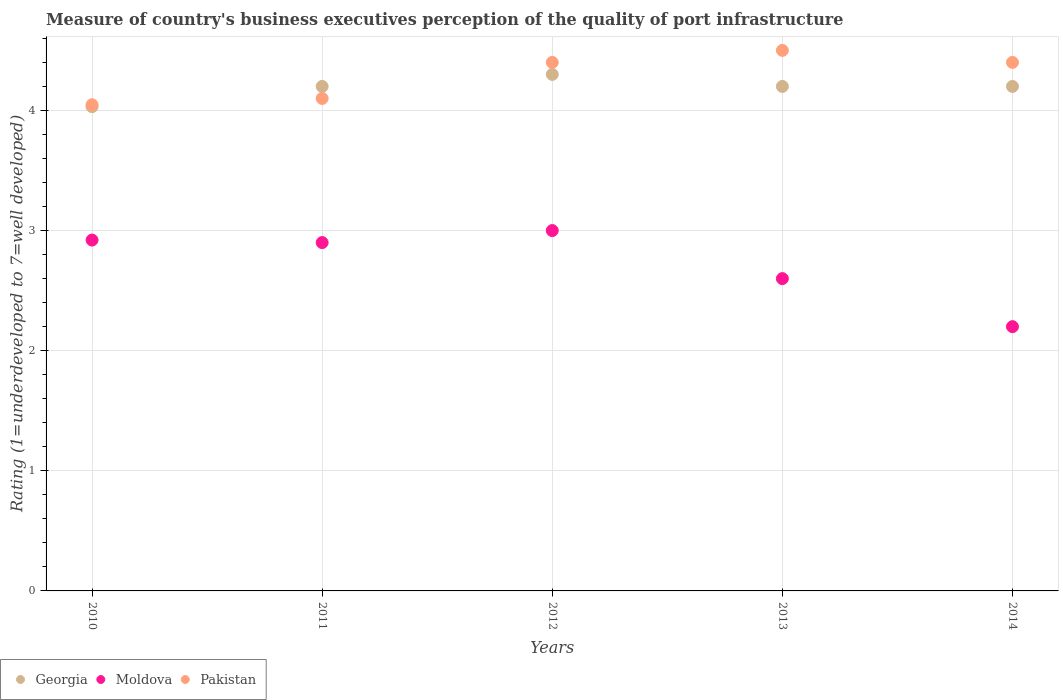How many different coloured dotlines are there?
Ensure brevity in your answer.  3. Across all years, what is the maximum ratings of the quality of port infrastructure in Georgia?
Provide a short and direct response. 4.3. Across all years, what is the minimum ratings of the quality of port infrastructure in Pakistan?
Your response must be concise. 4.05. What is the total ratings of the quality of port infrastructure in Pakistan in the graph?
Offer a terse response. 21.45. What is the difference between the ratings of the quality of port infrastructure in Pakistan in 2011 and that in 2013?
Offer a very short reply. -0.4. What is the difference between the ratings of the quality of port infrastructure in Moldova in 2013 and the ratings of the quality of port infrastructure in Pakistan in 2014?
Ensure brevity in your answer.  -1.8. What is the average ratings of the quality of port infrastructure in Moldova per year?
Your response must be concise. 2.72. In the year 2011, what is the difference between the ratings of the quality of port infrastructure in Georgia and ratings of the quality of port infrastructure in Moldova?
Make the answer very short. 1.3. What is the ratio of the ratings of the quality of port infrastructure in Pakistan in 2011 to that in 2013?
Offer a terse response. 0.91. Is the ratings of the quality of port infrastructure in Georgia in 2013 less than that in 2014?
Offer a terse response. No. What is the difference between the highest and the second highest ratings of the quality of port infrastructure in Moldova?
Your response must be concise. 0.08. What is the difference between the highest and the lowest ratings of the quality of port infrastructure in Pakistan?
Make the answer very short. 0.45. Is the sum of the ratings of the quality of port infrastructure in Pakistan in 2010 and 2013 greater than the maximum ratings of the quality of port infrastructure in Moldova across all years?
Offer a very short reply. Yes. Is it the case that in every year, the sum of the ratings of the quality of port infrastructure in Georgia and ratings of the quality of port infrastructure in Moldova  is greater than the ratings of the quality of port infrastructure in Pakistan?
Give a very brief answer. Yes. How many dotlines are there?
Ensure brevity in your answer.  3. Where does the legend appear in the graph?
Make the answer very short. Bottom left. What is the title of the graph?
Keep it short and to the point. Measure of country's business executives perception of the quality of port infrastructure. Does "Vanuatu" appear as one of the legend labels in the graph?
Make the answer very short. No. What is the label or title of the X-axis?
Provide a succinct answer. Years. What is the label or title of the Y-axis?
Your answer should be compact. Rating (1=underdeveloped to 7=well developed). What is the Rating (1=underdeveloped to 7=well developed) in Georgia in 2010?
Ensure brevity in your answer.  4.03. What is the Rating (1=underdeveloped to 7=well developed) of Moldova in 2010?
Offer a very short reply. 2.92. What is the Rating (1=underdeveloped to 7=well developed) in Pakistan in 2010?
Give a very brief answer. 4.05. What is the Rating (1=underdeveloped to 7=well developed) of Georgia in 2011?
Provide a short and direct response. 4.2. What is the Rating (1=underdeveloped to 7=well developed) in Moldova in 2011?
Give a very brief answer. 2.9. What is the Rating (1=underdeveloped to 7=well developed) in Pakistan in 2011?
Offer a terse response. 4.1. What is the Rating (1=underdeveloped to 7=well developed) of Georgia in 2012?
Your response must be concise. 4.3. What is the Rating (1=underdeveloped to 7=well developed) of Pakistan in 2012?
Provide a succinct answer. 4.4. What is the Rating (1=underdeveloped to 7=well developed) of Georgia in 2013?
Provide a succinct answer. 4.2. What is the Rating (1=underdeveloped to 7=well developed) in Pakistan in 2013?
Provide a short and direct response. 4.5. What is the Rating (1=underdeveloped to 7=well developed) in Georgia in 2014?
Provide a succinct answer. 4.2. What is the Rating (1=underdeveloped to 7=well developed) in Pakistan in 2014?
Keep it short and to the point. 4.4. Across all years, what is the maximum Rating (1=underdeveloped to 7=well developed) of Moldova?
Your answer should be compact. 3. Across all years, what is the minimum Rating (1=underdeveloped to 7=well developed) in Georgia?
Keep it short and to the point. 4.03. Across all years, what is the minimum Rating (1=underdeveloped to 7=well developed) in Pakistan?
Make the answer very short. 4.05. What is the total Rating (1=underdeveloped to 7=well developed) in Georgia in the graph?
Your response must be concise. 20.93. What is the total Rating (1=underdeveloped to 7=well developed) of Moldova in the graph?
Make the answer very short. 13.62. What is the total Rating (1=underdeveloped to 7=well developed) of Pakistan in the graph?
Your response must be concise. 21.45. What is the difference between the Rating (1=underdeveloped to 7=well developed) of Georgia in 2010 and that in 2011?
Offer a terse response. -0.17. What is the difference between the Rating (1=underdeveloped to 7=well developed) in Moldova in 2010 and that in 2011?
Provide a short and direct response. 0.02. What is the difference between the Rating (1=underdeveloped to 7=well developed) in Pakistan in 2010 and that in 2011?
Your answer should be compact. -0.05. What is the difference between the Rating (1=underdeveloped to 7=well developed) of Georgia in 2010 and that in 2012?
Make the answer very short. -0.27. What is the difference between the Rating (1=underdeveloped to 7=well developed) in Moldova in 2010 and that in 2012?
Your answer should be compact. -0.08. What is the difference between the Rating (1=underdeveloped to 7=well developed) of Pakistan in 2010 and that in 2012?
Offer a very short reply. -0.35. What is the difference between the Rating (1=underdeveloped to 7=well developed) of Georgia in 2010 and that in 2013?
Offer a very short reply. -0.17. What is the difference between the Rating (1=underdeveloped to 7=well developed) in Moldova in 2010 and that in 2013?
Provide a short and direct response. 0.32. What is the difference between the Rating (1=underdeveloped to 7=well developed) in Pakistan in 2010 and that in 2013?
Your answer should be very brief. -0.45. What is the difference between the Rating (1=underdeveloped to 7=well developed) in Georgia in 2010 and that in 2014?
Make the answer very short. -0.17. What is the difference between the Rating (1=underdeveloped to 7=well developed) in Moldova in 2010 and that in 2014?
Your response must be concise. 0.72. What is the difference between the Rating (1=underdeveloped to 7=well developed) in Pakistan in 2010 and that in 2014?
Your answer should be compact. -0.35. What is the difference between the Rating (1=underdeveloped to 7=well developed) of Georgia in 2011 and that in 2013?
Your answer should be very brief. 0. What is the difference between the Rating (1=underdeveloped to 7=well developed) in Pakistan in 2011 and that in 2013?
Make the answer very short. -0.4. What is the difference between the Rating (1=underdeveloped to 7=well developed) of Pakistan in 2011 and that in 2014?
Provide a succinct answer. -0.3. What is the difference between the Rating (1=underdeveloped to 7=well developed) of Moldova in 2012 and that in 2013?
Keep it short and to the point. 0.4. What is the difference between the Rating (1=underdeveloped to 7=well developed) of Pakistan in 2012 and that in 2013?
Ensure brevity in your answer.  -0.1. What is the difference between the Rating (1=underdeveloped to 7=well developed) in Moldova in 2012 and that in 2014?
Give a very brief answer. 0.8. What is the difference between the Rating (1=underdeveloped to 7=well developed) in Georgia in 2013 and that in 2014?
Your answer should be very brief. 0. What is the difference between the Rating (1=underdeveloped to 7=well developed) in Georgia in 2010 and the Rating (1=underdeveloped to 7=well developed) in Moldova in 2011?
Give a very brief answer. 1.13. What is the difference between the Rating (1=underdeveloped to 7=well developed) of Georgia in 2010 and the Rating (1=underdeveloped to 7=well developed) of Pakistan in 2011?
Offer a terse response. -0.07. What is the difference between the Rating (1=underdeveloped to 7=well developed) in Moldova in 2010 and the Rating (1=underdeveloped to 7=well developed) in Pakistan in 2011?
Give a very brief answer. -1.18. What is the difference between the Rating (1=underdeveloped to 7=well developed) in Georgia in 2010 and the Rating (1=underdeveloped to 7=well developed) in Moldova in 2012?
Offer a terse response. 1.03. What is the difference between the Rating (1=underdeveloped to 7=well developed) of Georgia in 2010 and the Rating (1=underdeveloped to 7=well developed) of Pakistan in 2012?
Your response must be concise. -0.37. What is the difference between the Rating (1=underdeveloped to 7=well developed) in Moldova in 2010 and the Rating (1=underdeveloped to 7=well developed) in Pakistan in 2012?
Your answer should be very brief. -1.48. What is the difference between the Rating (1=underdeveloped to 7=well developed) of Georgia in 2010 and the Rating (1=underdeveloped to 7=well developed) of Moldova in 2013?
Ensure brevity in your answer.  1.43. What is the difference between the Rating (1=underdeveloped to 7=well developed) in Georgia in 2010 and the Rating (1=underdeveloped to 7=well developed) in Pakistan in 2013?
Make the answer very short. -0.47. What is the difference between the Rating (1=underdeveloped to 7=well developed) of Moldova in 2010 and the Rating (1=underdeveloped to 7=well developed) of Pakistan in 2013?
Keep it short and to the point. -1.58. What is the difference between the Rating (1=underdeveloped to 7=well developed) in Georgia in 2010 and the Rating (1=underdeveloped to 7=well developed) in Moldova in 2014?
Make the answer very short. 1.83. What is the difference between the Rating (1=underdeveloped to 7=well developed) in Georgia in 2010 and the Rating (1=underdeveloped to 7=well developed) in Pakistan in 2014?
Offer a very short reply. -0.37. What is the difference between the Rating (1=underdeveloped to 7=well developed) of Moldova in 2010 and the Rating (1=underdeveloped to 7=well developed) of Pakistan in 2014?
Provide a succinct answer. -1.48. What is the difference between the Rating (1=underdeveloped to 7=well developed) in Georgia in 2011 and the Rating (1=underdeveloped to 7=well developed) in Moldova in 2012?
Your answer should be compact. 1.2. What is the difference between the Rating (1=underdeveloped to 7=well developed) in Georgia in 2011 and the Rating (1=underdeveloped to 7=well developed) in Pakistan in 2012?
Ensure brevity in your answer.  -0.2. What is the difference between the Rating (1=underdeveloped to 7=well developed) of Georgia in 2011 and the Rating (1=underdeveloped to 7=well developed) of Pakistan in 2014?
Keep it short and to the point. -0.2. What is the difference between the Rating (1=underdeveloped to 7=well developed) of Georgia in 2012 and the Rating (1=underdeveloped to 7=well developed) of Pakistan in 2013?
Your response must be concise. -0.2. What is the difference between the Rating (1=underdeveloped to 7=well developed) of Moldova in 2012 and the Rating (1=underdeveloped to 7=well developed) of Pakistan in 2013?
Give a very brief answer. -1.5. What is the difference between the Rating (1=underdeveloped to 7=well developed) of Georgia in 2012 and the Rating (1=underdeveloped to 7=well developed) of Pakistan in 2014?
Ensure brevity in your answer.  -0.1. What is the difference between the Rating (1=underdeveloped to 7=well developed) in Georgia in 2013 and the Rating (1=underdeveloped to 7=well developed) in Moldova in 2014?
Offer a terse response. 2. What is the difference between the Rating (1=underdeveloped to 7=well developed) in Moldova in 2013 and the Rating (1=underdeveloped to 7=well developed) in Pakistan in 2014?
Your answer should be very brief. -1.8. What is the average Rating (1=underdeveloped to 7=well developed) in Georgia per year?
Your answer should be very brief. 4.19. What is the average Rating (1=underdeveloped to 7=well developed) of Moldova per year?
Ensure brevity in your answer.  2.72. What is the average Rating (1=underdeveloped to 7=well developed) in Pakistan per year?
Provide a short and direct response. 4.29. In the year 2010, what is the difference between the Rating (1=underdeveloped to 7=well developed) in Georgia and Rating (1=underdeveloped to 7=well developed) in Moldova?
Your answer should be compact. 1.11. In the year 2010, what is the difference between the Rating (1=underdeveloped to 7=well developed) of Georgia and Rating (1=underdeveloped to 7=well developed) of Pakistan?
Keep it short and to the point. -0.02. In the year 2010, what is the difference between the Rating (1=underdeveloped to 7=well developed) of Moldova and Rating (1=underdeveloped to 7=well developed) of Pakistan?
Provide a short and direct response. -1.13. In the year 2011, what is the difference between the Rating (1=underdeveloped to 7=well developed) of Georgia and Rating (1=underdeveloped to 7=well developed) of Moldova?
Your answer should be compact. 1.3. In the year 2011, what is the difference between the Rating (1=underdeveloped to 7=well developed) of Georgia and Rating (1=underdeveloped to 7=well developed) of Pakistan?
Provide a short and direct response. 0.1. In the year 2012, what is the difference between the Rating (1=underdeveloped to 7=well developed) of Georgia and Rating (1=underdeveloped to 7=well developed) of Moldova?
Offer a terse response. 1.3. In the year 2012, what is the difference between the Rating (1=underdeveloped to 7=well developed) in Georgia and Rating (1=underdeveloped to 7=well developed) in Pakistan?
Provide a short and direct response. -0.1. In the year 2013, what is the difference between the Rating (1=underdeveloped to 7=well developed) of Georgia and Rating (1=underdeveloped to 7=well developed) of Pakistan?
Your answer should be compact. -0.3. In the year 2014, what is the difference between the Rating (1=underdeveloped to 7=well developed) of Georgia and Rating (1=underdeveloped to 7=well developed) of Pakistan?
Your response must be concise. -0.2. In the year 2014, what is the difference between the Rating (1=underdeveloped to 7=well developed) in Moldova and Rating (1=underdeveloped to 7=well developed) in Pakistan?
Give a very brief answer. -2.2. What is the ratio of the Rating (1=underdeveloped to 7=well developed) of Georgia in 2010 to that in 2011?
Provide a succinct answer. 0.96. What is the ratio of the Rating (1=underdeveloped to 7=well developed) in Pakistan in 2010 to that in 2011?
Ensure brevity in your answer.  0.99. What is the ratio of the Rating (1=underdeveloped to 7=well developed) of Georgia in 2010 to that in 2012?
Ensure brevity in your answer.  0.94. What is the ratio of the Rating (1=underdeveloped to 7=well developed) in Moldova in 2010 to that in 2012?
Offer a very short reply. 0.97. What is the ratio of the Rating (1=underdeveloped to 7=well developed) of Pakistan in 2010 to that in 2012?
Your answer should be compact. 0.92. What is the ratio of the Rating (1=underdeveloped to 7=well developed) of Georgia in 2010 to that in 2013?
Keep it short and to the point. 0.96. What is the ratio of the Rating (1=underdeveloped to 7=well developed) of Moldova in 2010 to that in 2013?
Ensure brevity in your answer.  1.12. What is the ratio of the Rating (1=underdeveloped to 7=well developed) of Pakistan in 2010 to that in 2013?
Provide a short and direct response. 0.9. What is the ratio of the Rating (1=underdeveloped to 7=well developed) of Georgia in 2010 to that in 2014?
Give a very brief answer. 0.96. What is the ratio of the Rating (1=underdeveloped to 7=well developed) of Moldova in 2010 to that in 2014?
Provide a succinct answer. 1.33. What is the ratio of the Rating (1=underdeveloped to 7=well developed) of Pakistan in 2010 to that in 2014?
Keep it short and to the point. 0.92. What is the ratio of the Rating (1=underdeveloped to 7=well developed) of Georgia in 2011 to that in 2012?
Your answer should be very brief. 0.98. What is the ratio of the Rating (1=underdeveloped to 7=well developed) in Moldova in 2011 to that in 2012?
Keep it short and to the point. 0.97. What is the ratio of the Rating (1=underdeveloped to 7=well developed) of Pakistan in 2011 to that in 2012?
Ensure brevity in your answer.  0.93. What is the ratio of the Rating (1=underdeveloped to 7=well developed) in Moldova in 2011 to that in 2013?
Your response must be concise. 1.12. What is the ratio of the Rating (1=underdeveloped to 7=well developed) of Pakistan in 2011 to that in 2013?
Make the answer very short. 0.91. What is the ratio of the Rating (1=underdeveloped to 7=well developed) in Georgia in 2011 to that in 2014?
Ensure brevity in your answer.  1. What is the ratio of the Rating (1=underdeveloped to 7=well developed) of Moldova in 2011 to that in 2014?
Your answer should be compact. 1.32. What is the ratio of the Rating (1=underdeveloped to 7=well developed) in Pakistan in 2011 to that in 2014?
Provide a succinct answer. 0.93. What is the ratio of the Rating (1=underdeveloped to 7=well developed) in Georgia in 2012 to that in 2013?
Give a very brief answer. 1.02. What is the ratio of the Rating (1=underdeveloped to 7=well developed) in Moldova in 2012 to that in 2013?
Your answer should be compact. 1.15. What is the ratio of the Rating (1=underdeveloped to 7=well developed) of Pakistan in 2012 to that in 2013?
Keep it short and to the point. 0.98. What is the ratio of the Rating (1=underdeveloped to 7=well developed) in Georgia in 2012 to that in 2014?
Your answer should be compact. 1.02. What is the ratio of the Rating (1=underdeveloped to 7=well developed) in Moldova in 2012 to that in 2014?
Make the answer very short. 1.36. What is the ratio of the Rating (1=underdeveloped to 7=well developed) in Pakistan in 2012 to that in 2014?
Your answer should be very brief. 1. What is the ratio of the Rating (1=underdeveloped to 7=well developed) of Moldova in 2013 to that in 2014?
Offer a very short reply. 1.18. What is the ratio of the Rating (1=underdeveloped to 7=well developed) of Pakistan in 2013 to that in 2014?
Offer a terse response. 1.02. What is the difference between the highest and the second highest Rating (1=underdeveloped to 7=well developed) in Moldova?
Provide a succinct answer. 0.08. What is the difference between the highest and the lowest Rating (1=underdeveloped to 7=well developed) of Georgia?
Ensure brevity in your answer.  0.27. What is the difference between the highest and the lowest Rating (1=underdeveloped to 7=well developed) of Pakistan?
Your answer should be compact. 0.45. 